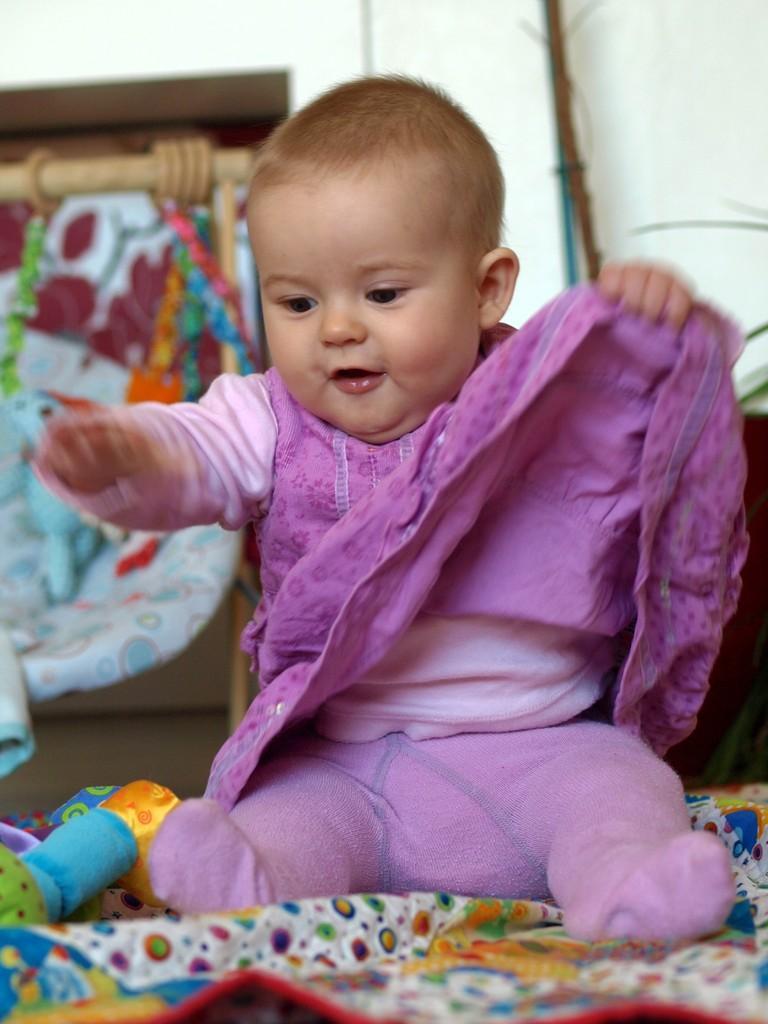Can you describe this image briefly? In this picture there is a small baby in the center of the image, on a bed and there are toys at the bottom side of the image and there is a cradle in the background area of the image. 